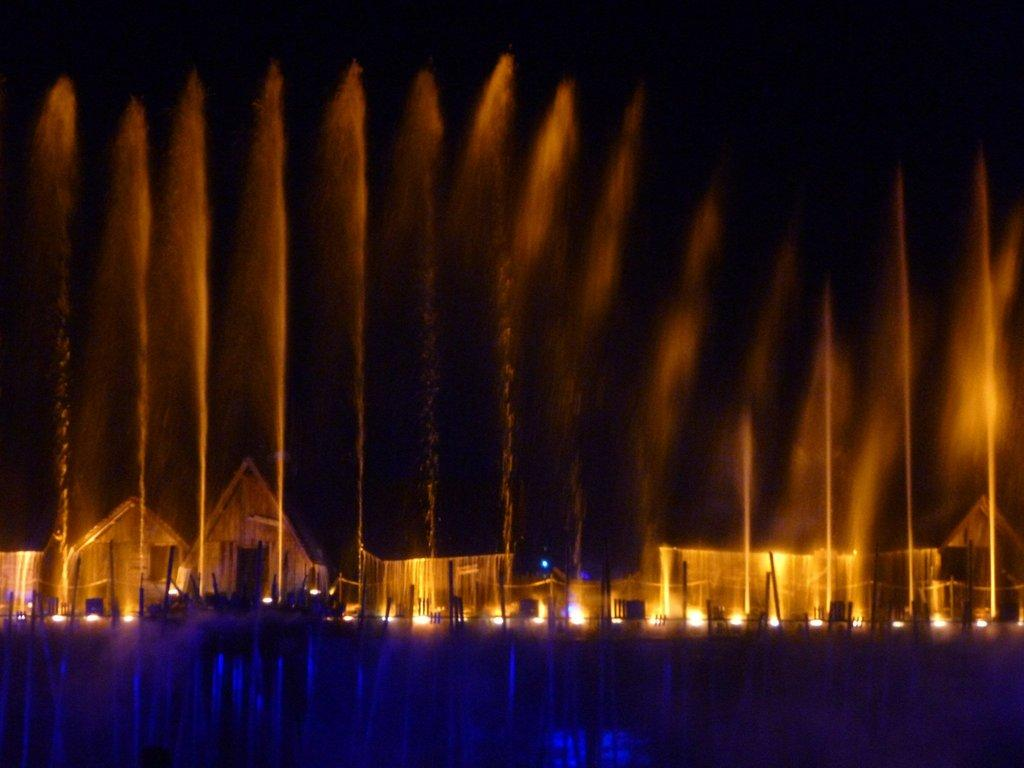What type of structures are present in the image? There are water fountains in the image. What can be seen in the distance behind the water fountains? There are houses visible in the background of the image. Are there any additional features on the land in the image? Yes, there are lights on the land in the image. What type of farm animals can be seen grazing in the aftermath of the image? There is no farm or aftermath present in the image; it features water fountains and houses in the background. 